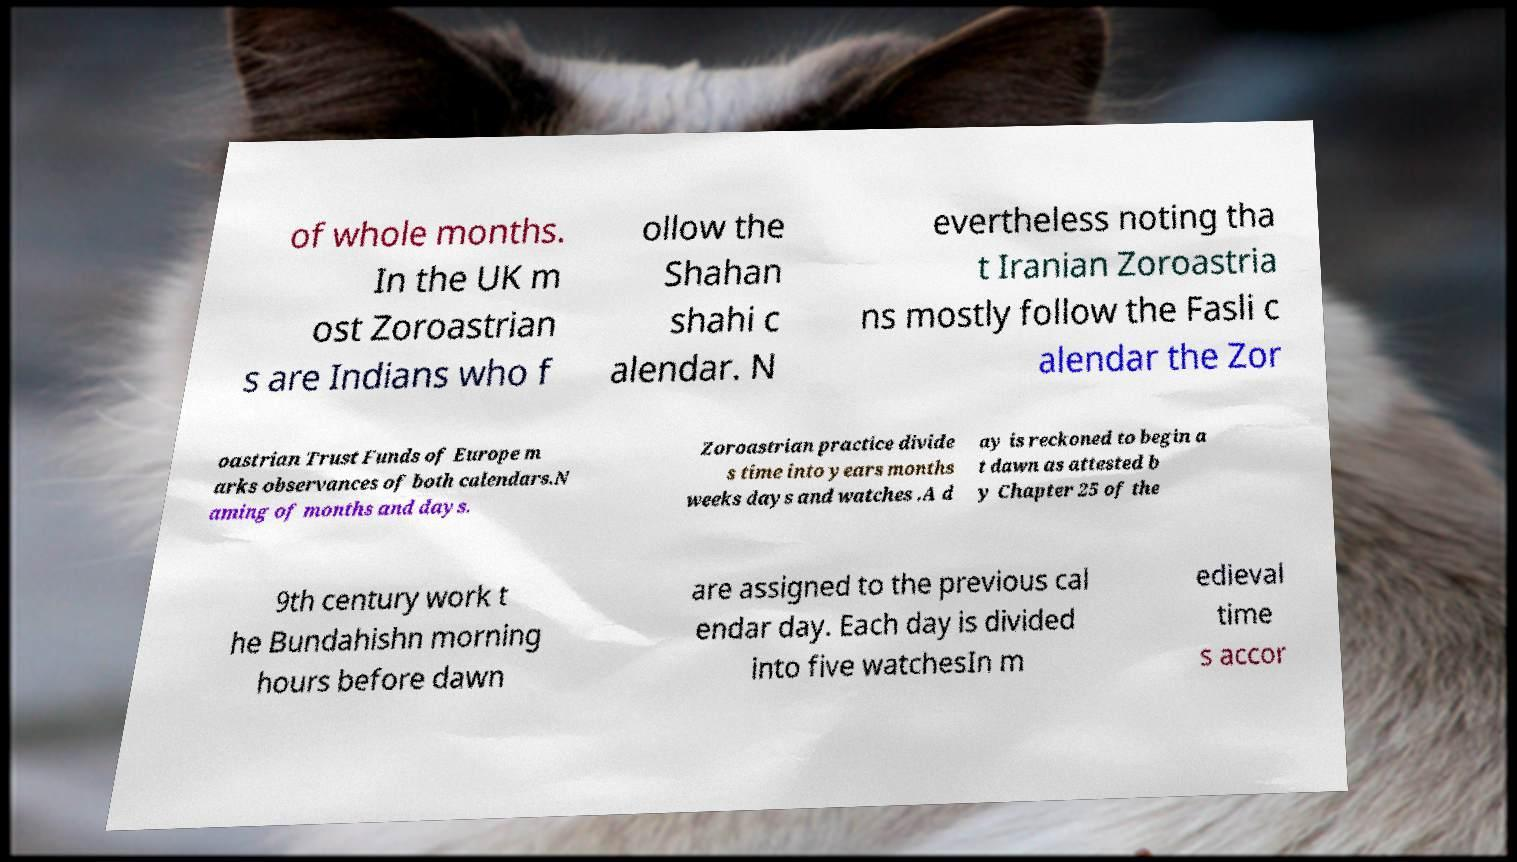What messages or text are displayed in this image? I need them in a readable, typed format. of whole months. In the UK m ost Zoroastrian s are Indians who f ollow the Shahan shahi c alendar. N evertheless noting tha t Iranian Zoroastria ns mostly follow the Fasli c alendar the Zor oastrian Trust Funds of Europe m arks observances of both calendars.N aming of months and days. Zoroastrian practice divide s time into years months weeks days and watches .A d ay is reckoned to begin a t dawn as attested b y Chapter 25 of the 9th century work t he Bundahishn morning hours before dawn are assigned to the previous cal endar day. Each day is divided into five watchesIn m edieval time s accor 